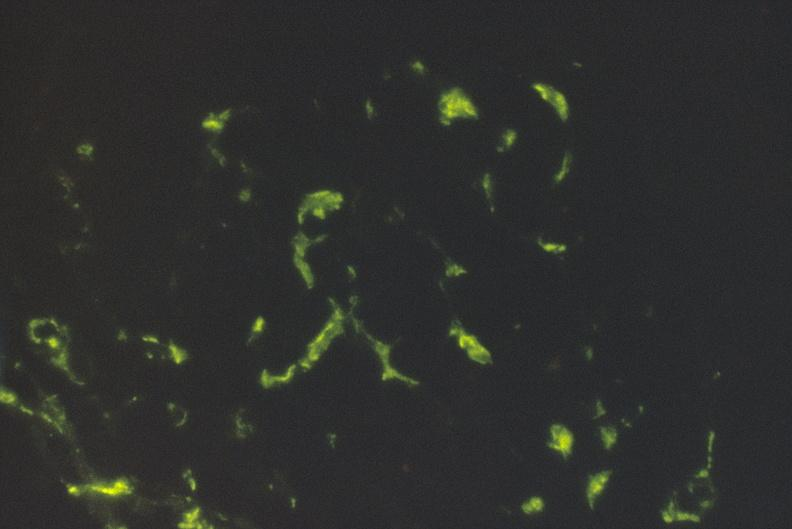what is present?
Answer the question using a single word or phrase. Urinary 